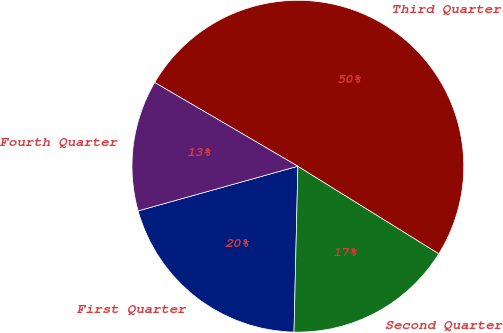<chart> <loc_0><loc_0><loc_500><loc_500><pie_chart><fcel>First Quarter<fcel>Second Quarter<fcel>Third Quarter<fcel>Fourth Quarter<nl><fcel>20.29%<fcel>16.53%<fcel>50.42%<fcel>12.76%<nl></chart> 